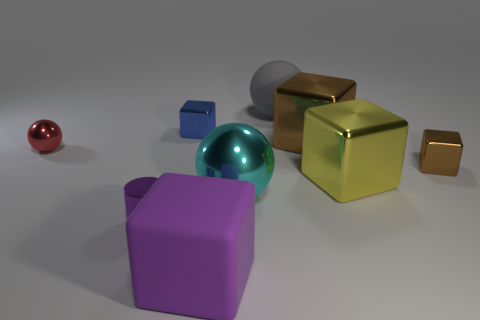There is a small purple metal cylinder; what number of gray objects are on the left side of it?
Offer a terse response. 0. There is another metal thing that is the same shape as the big cyan shiny object; what color is it?
Your response must be concise. Red. Is the material of the brown block that is on the left side of the yellow thing the same as the big ball that is behind the tiny brown block?
Offer a terse response. No. There is a small cylinder; is it the same color as the big thing that is in front of the cylinder?
Give a very brief answer. Yes. There is a tiny metal thing that is on the left side of the blue metal block and behind the small purple shiny object; what is its shape?
Your response must be concise. Sphere. How many large gray things are there?
Your answer should be compact. 1. What is the shape of the thing that is the same color as the large matte cube?
Ensure brevity in your answer.  Cylinder. There is a purple matte thing that is the same shape as the big brown thing; what is its size?
Your response must be concise. Large. There is a large matte thing behind the small purple cylinder; is it the same shape as the tiny red metal thing?
Offer a very short reply. Yes. There is a big rubber thing behind the purple cylinder; what color is it?
Make the answer very short. Gray. 